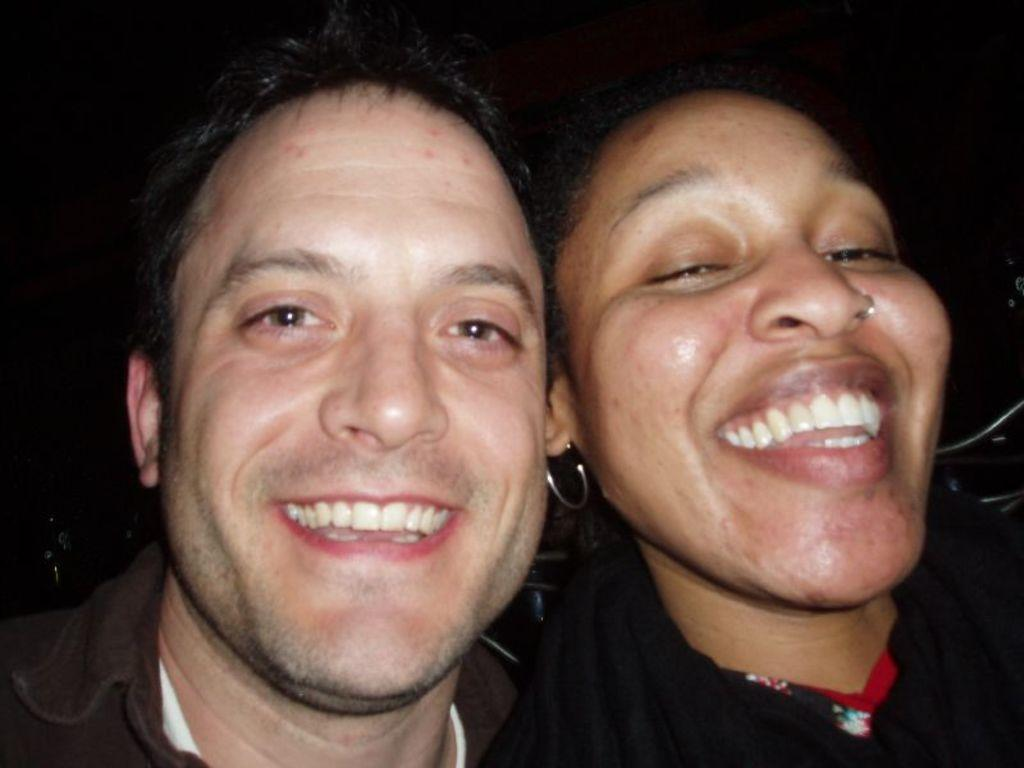How many people are in the image? There are two people in the image. What is the facial expression of the people in the image? The people are smiling. What can be seen in the background of the image? The background of the image contains objects. How would you describe the lighting in the image? The image appears to be dark. What time of day is it in the image, specifically in the afternoon? The provided facts do not mention the time of day, so it cannot be determined if the image is set in the afternoon. 